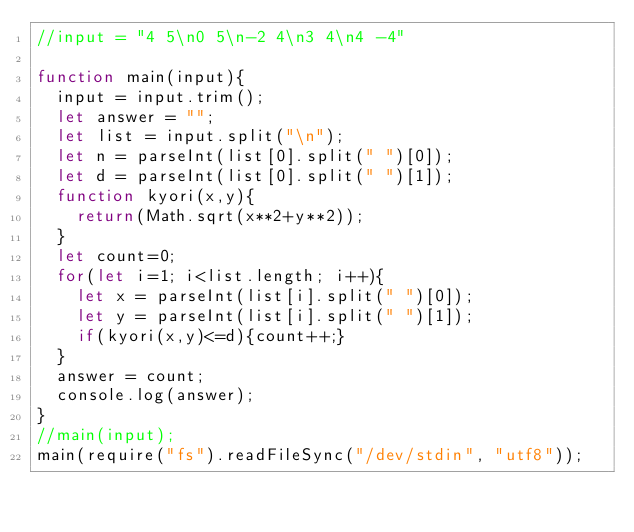<code> <loc_0><loc_0><loc_500><loc_500><_JavaScript_>//input = "4 5\n0 5\n-2 4\n3 4\n4 -4"

function main(input){
  input = input.trim();
  let answer = "";
  let list = input.split("\n");
  let n = parseInt(list[0].split(" ")[0]);
  let d = parseInt(list[0].split(" ")[1]);
  function kyori(x,y){
    return(Math.sqrt(x**2+y**2));
  }
  let count=0;
  for(let i=1; i<list.length; i++){
    let x = parseInt(list[i].split(" ")[0]);
    let y = parseInt(list[i].split(" ")[1]);
    if(kyori(x,y)<=d){count++;}
  }
  answer = count;
  console.log(answer);
}
//main(input);
main(require("fs").readFileSync("/dev/stdin", "utf8"));
</code> 